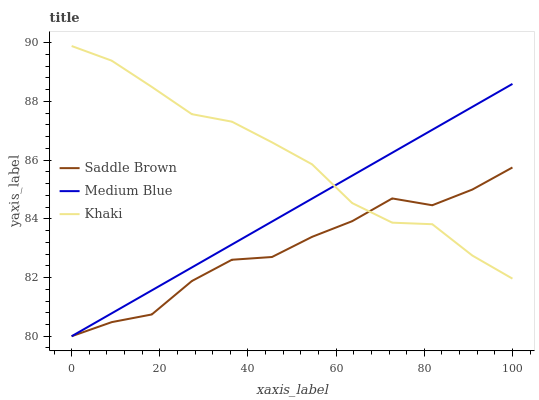Does Saddle Brown have the minimum area under the curve?
Answer yes or no. Yes. Does Khaki have the maximum area under the curve?
Answer yes or no. Yes. Does Medium Blue have the minimum area under the curve?
Answer yes or no. No. Does Medium Blue have the maximum area under the curve?
Answer yes or no. No. Is Medium Blue the smoothest?
Answer yes or no. Yes. Is Saddle Brown the roughest?
Answer yes or no. Yes. Is Saddle Brown the smoothest?
Answer yes or no. No. Is Medium Blue the roughest?
Answer yes or no. No. Does Medium Blue have the lowest value?
Answer yes or no. Yes. Does Khaki have the highest value?
Answer yes or no. Yes. Does Medium Blue have the highest value?
Answer yes or no. No. Does Khaki intersect Saddle Brown?
Answer yes or no. Yes. Is Khaki less than Saddle Brown?
Answer yes or no. No. Is Khaki greater than Saddle Brown?
Answer yes or no. No. 